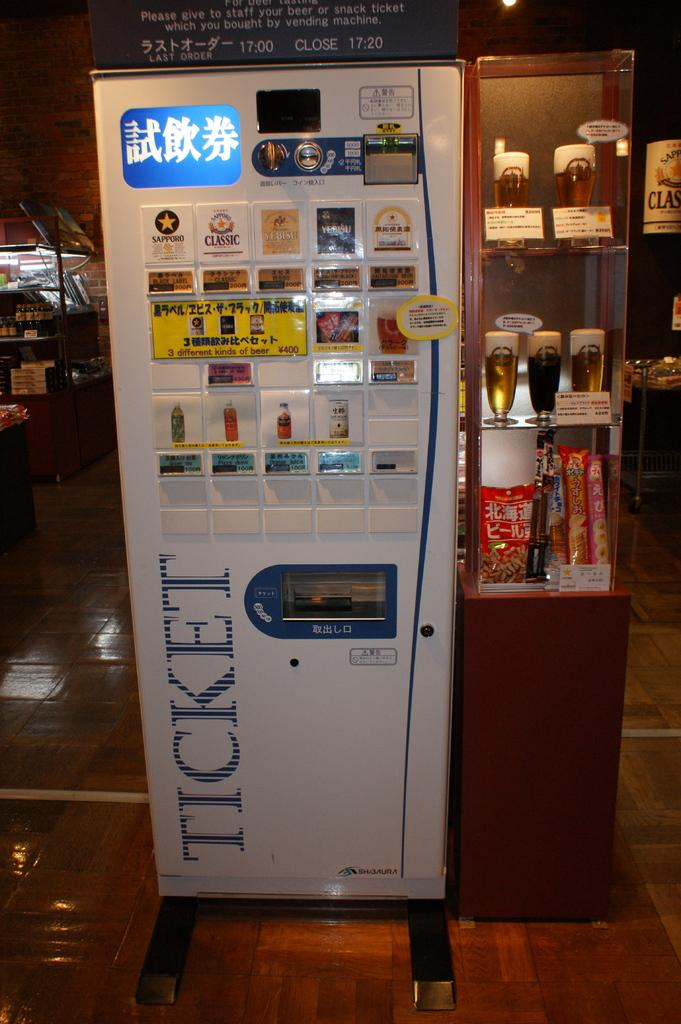<image>
Describe the image concisely. a machine that had the option that said 'sapporo' and 'ticket' on it 